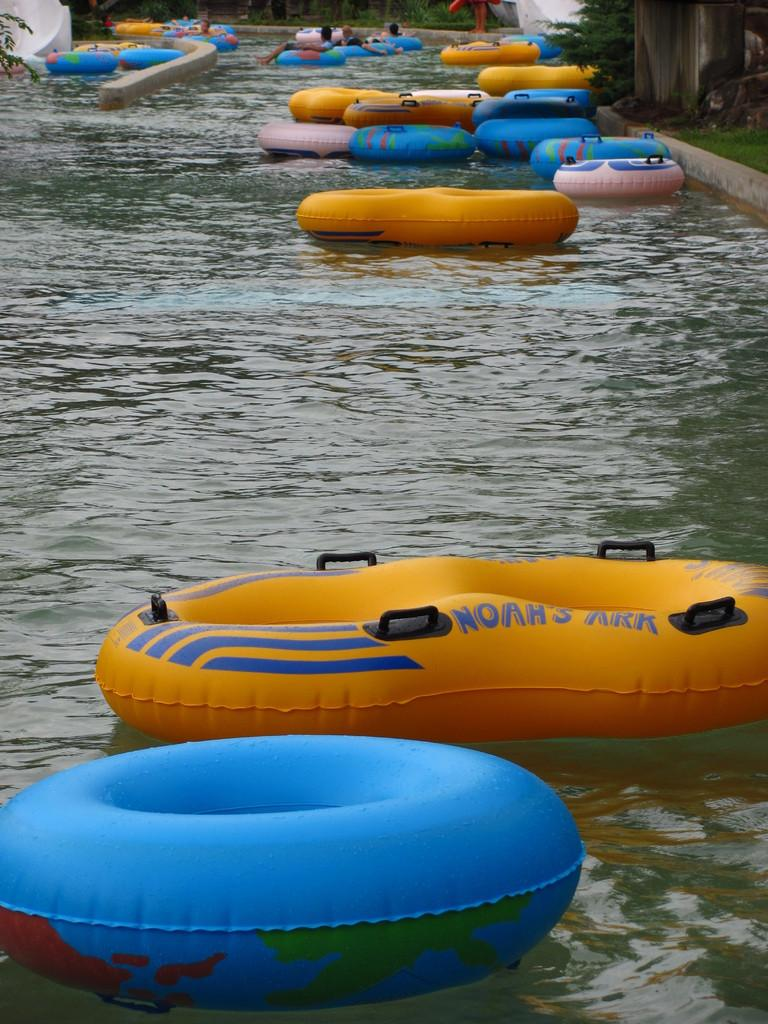What is floating on the water surface in the image? There are tubes on the water surface in the image. What are the people in the background doing? The people in the background are lying on tubes. What can be seen in the distance in the image? There are trees visible in the background of the image. What is the approval rating of the cent in the image? There is no mention of a cent or approval rating in the image; it features tubes on the water surface and people lying on them. How many waves can be seen in the image? There are no waves visible in the image; it shows tubes on the water surface and people lying on them. 